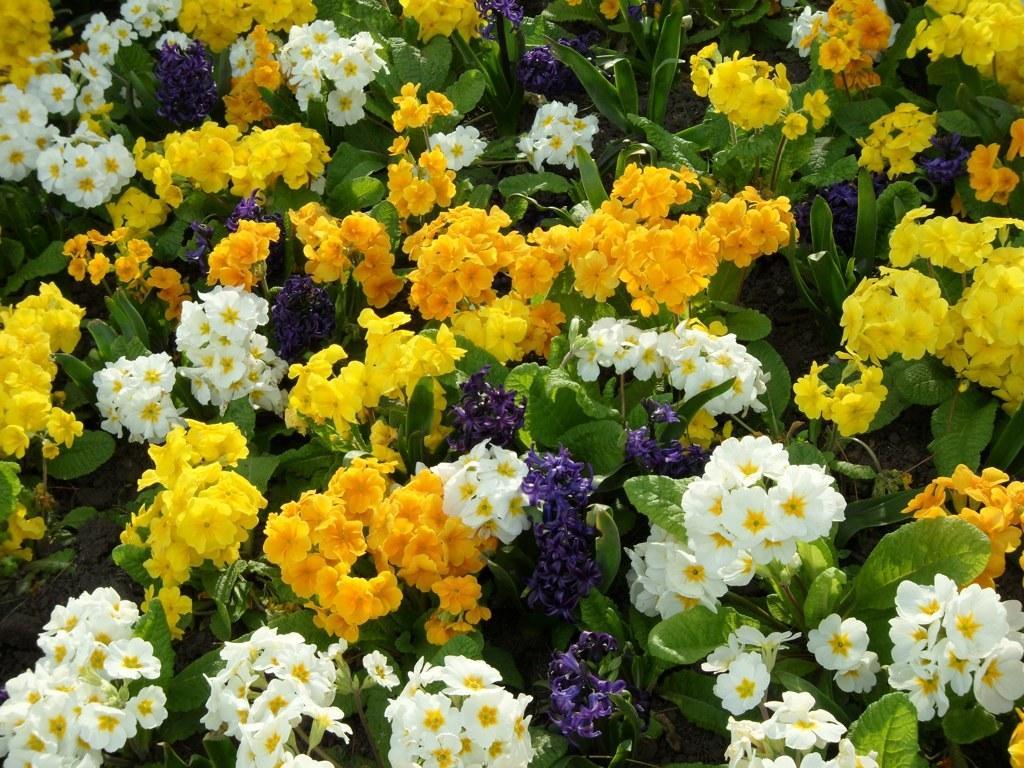Can you describe this image briefly? In this picture we can see yellow, white and purple color flowers on the plant. At the bottom we can see the leaves. 